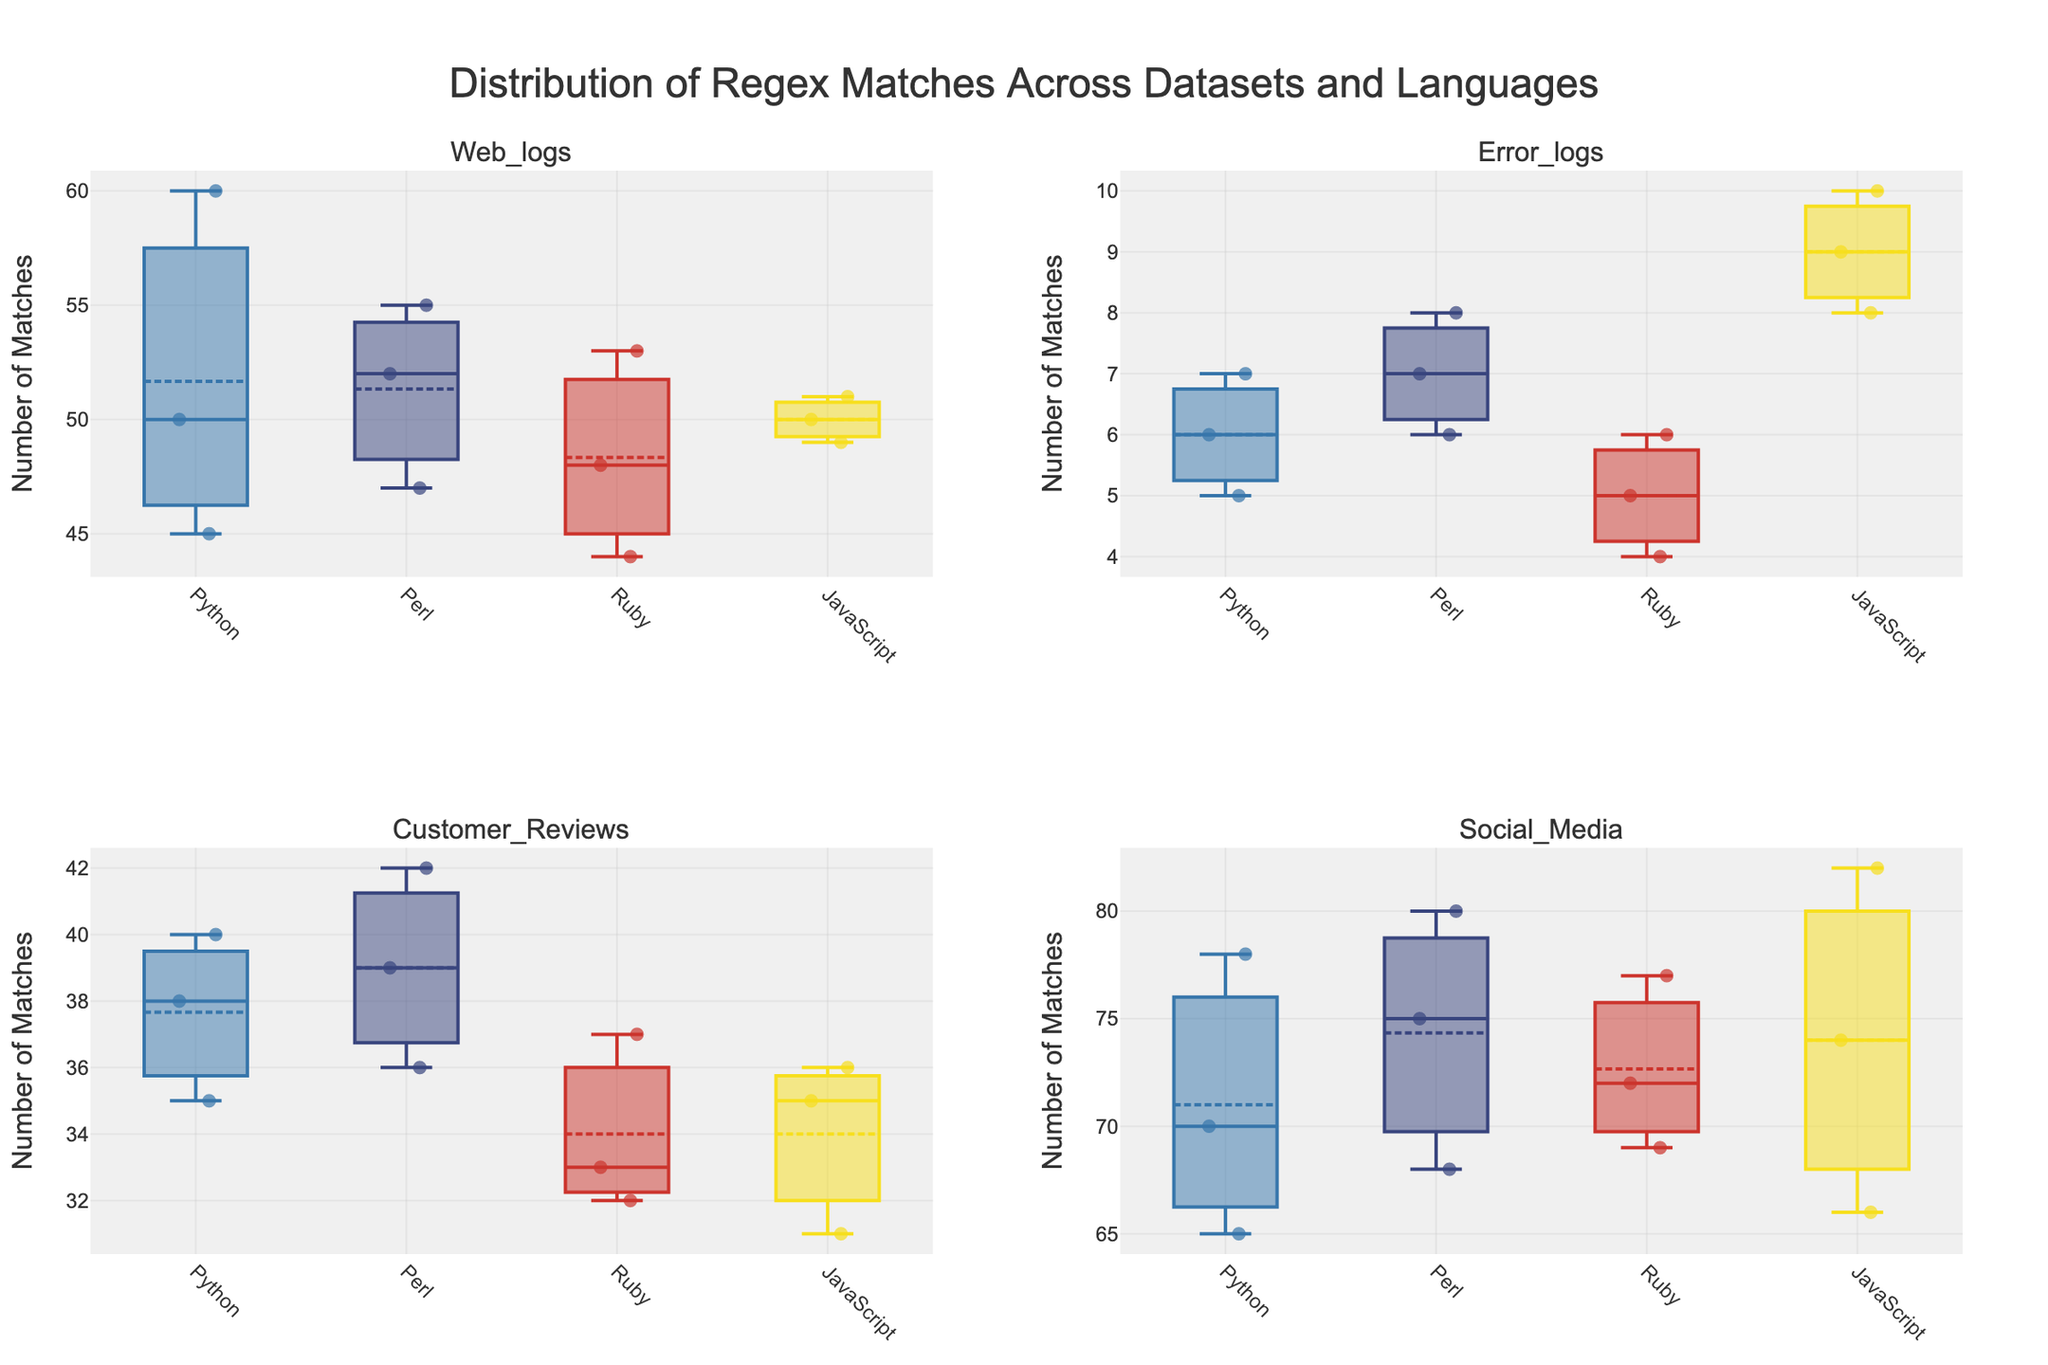What's the title of the figure? The title of the figure is typically shown at the top of the plot. Referring to the plot's title, we can read: 'Distribution of Regex Matches Across Datasets and Languages'.
Answer: Distribution of Regex Matches Across Datasets and Languages Which language shows the highest number of regex matches in the Social Media dataset? By looking at the box plots specifically for the Social Media dataset, we can identify the one with the highest maximum value within the dataset. The highest number of matches is observed in JavaScript.
Answer: JavaScript What is the median number of matches found in Error_logs by Perl? The median is indicated by the line within the box of the box plot. From the Perl box plot in the Error_logs subplot, we observe that the median is around 7.
Answer: 7 How does the range of matches in Web_logs for Python compare to those for Ruby? The range is determined by the difference between the maximum and minimum values. For Python in Web_logs, the range is 60-45=15. For Ruby in Web_logs, the range is 53-44=9. Therefore, Python has a larger range.
Answer: Python has a larger range Which dataset has the least number of regex matches for Python, based on the medians? The medians can be identified by the lines inside each box plot. For Python, the medians of the datasets can be compared. The Error_logs dataset shows the least median among all, around 6.
Answer: Error_logs What's the interquartile range (IQR) of matches found by JavaScript in the Social Media dataset? The IQR is calculated as the difference between the third quartile (Q3) and the first quartile (Q1). Observing the JavaScript box plot for Social Media, Q3 is around 78, and Q1 is around 70. Therefore, IQR = 78 - 70 = 8.
Answer: 8 Which language shows the smallest variability in the number of regex matches for Customer_Reviews? Variability is seen by the spread of the box plot. The smallest box for Customer_Reviews is observed in JavaScript, indicating the least variability.
Answer: JavaScript Compare the median regex matches in the Customer_Reviews dataset across all languages. By looking at the median line in each box plot for Customer_Reviews, we have these medians: Python (around 38), Perl (around 39), Ruby (around 33), and JavaScript (around 35). Perl has the highest median among them.
Answer: Perl has the highest median What's the mean number of matches found by Ruby in the Web_logs dataset? The mean is available if box mean is shown in the plot. For Ruby in Web_logs, the mean is indicated by the small triangle markers which show around 48.
Answer: 48 